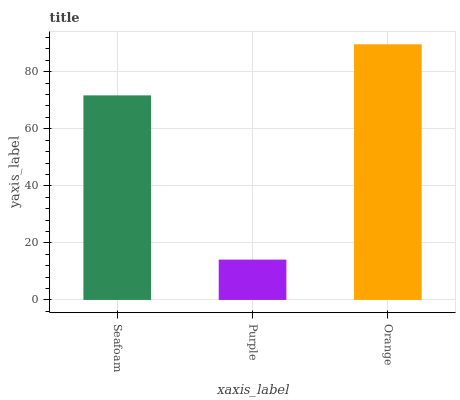Is Purple the minimum?
Answer yes or no. Yes. Is Orange the maximum?
Answer yes or no. Yes. Is Orange the minimum?
Answer yes or no. No. Is Purple the maximum?
Answer yes or no. No. Is Orange greater than Purple?
Answer yes or no. Yes. Is Purple less than Orange?
Answer yes or no. Yes. Is Purple greater than Orange?
Answer yes or no. No. Is Orange less than Purple?
Answer yes or no. No. Is Seafoam the high median?
Answer yes or no. Yes. Is Seafoam the low median?
Answer yes or no. Yes. Is Orange the high median?
Answer yes or no. No. Is Purple the low median?
Answer yes or no. No. 